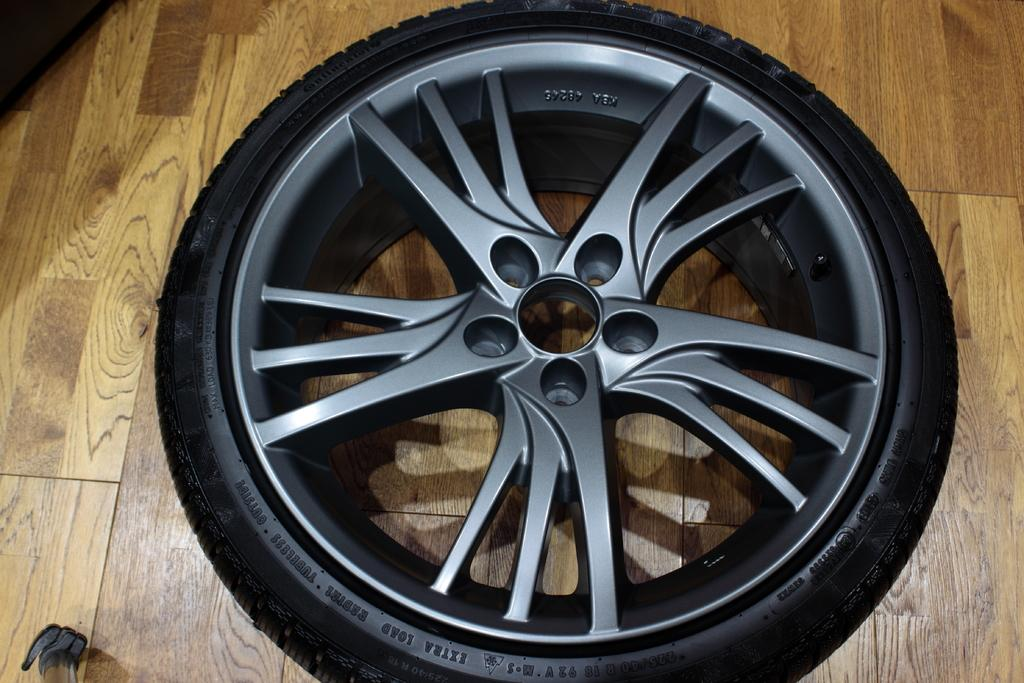What can be seen on the surface in the image? There is a wheel on the surface in the image. What objects are partially visible in the image? There is an object truncated towards the left of the image and another object truncated towards the bottom of the image. How many people are visible in the image? There are no people visible in the image. What type of frogs can be seen in the image? There are no frogs present in the image. 